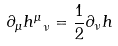<formula> <loc_0><loc_0><loc_500><loc_500>\partial _ { \mu } h ^ { \mu } _ { \ \nu } = \frac { 1 } { 2 } \partial _ { \nu } h</formula> 